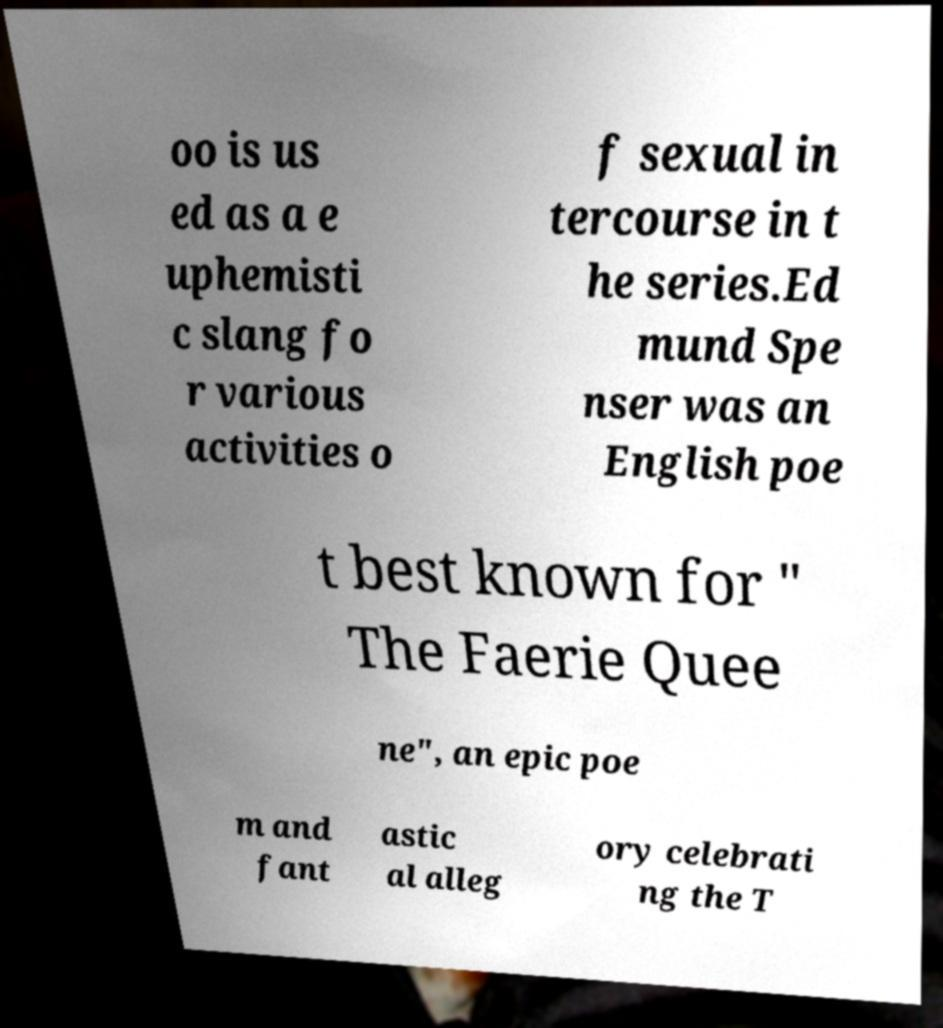For documentation purposes, I need the text within this image transcribed. Could you provide that? oo is us ed as a e uphemisti c slang fo r various activities o f sexual in tercourse in t he series.Ed mund Spe nser was an English poe t best known for " The Faerie Quee ne", an epic poe m and fant astic al alleg ory celebrati ng the T 